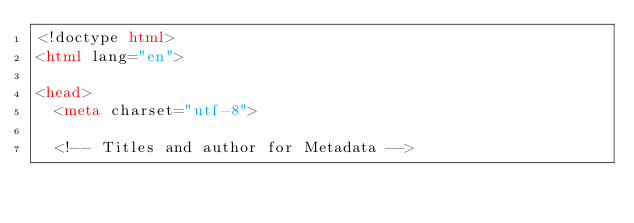<code> <loc_0><loc_0><loc_500><loc_500><_HTML_><!doctype html>
<html lang="en">

<head>
	<meta charset="utf-8">
	
	<!-- Titles and author for Metadata --></code> 